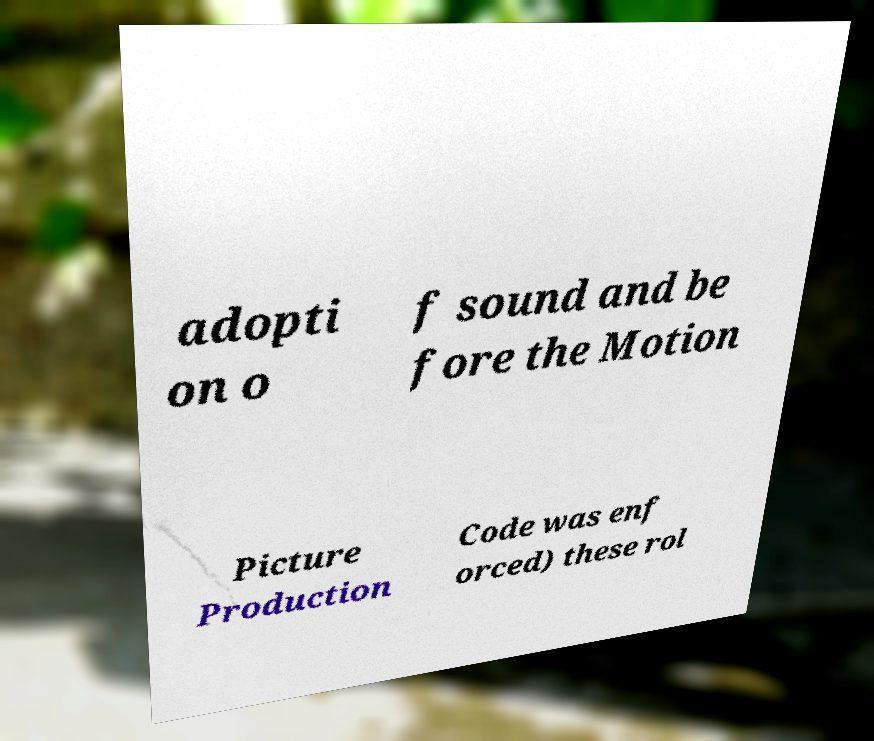Please identify and transcribe the text found in this image. adopti on o f sound and be fore the Motion Picture Production Code was enf orced) these rol 